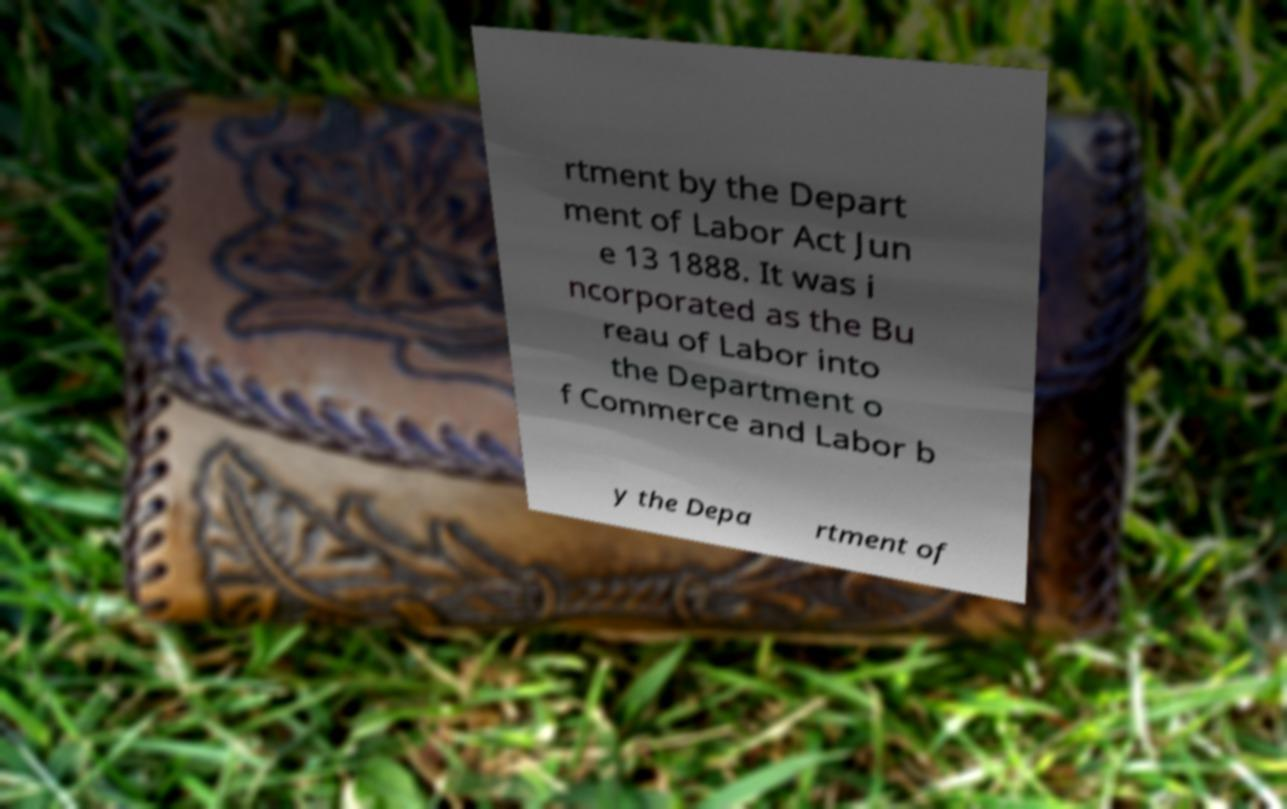Could you extract and type out the text from this image? rtment by the Depart ment of Labor Act Jun e 13 1888. It was i ncorporated as the Bu reau of Labor into the Department o f Commerce and Labor b y the Depa rtment of 